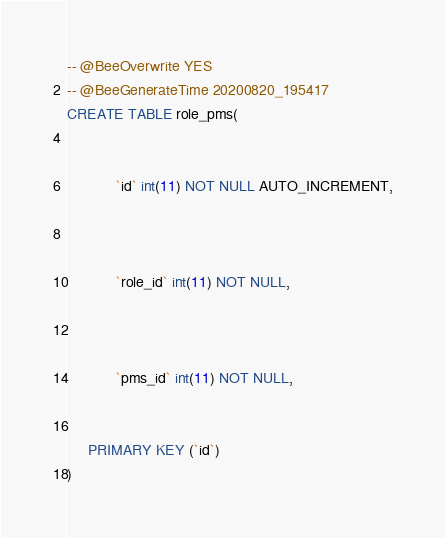Convert code to text. <code><loc_0><loc_0><loc_500><loc_500><_SQL_>-- @BeeOverwrite YES
-- @BeeGenerateTime 20200820_195417
CREATE TABLE role_pms(
     
        
            `id` int(11) NOT NULL AUTO_INCREMENT,
        
     
        
            `role_id` int(11) NOT NULL,
        
     
        
            `pms_id` int(11) NOT NULL,
        
     
     PRIMARY KEY (`id`)
)
</code> 